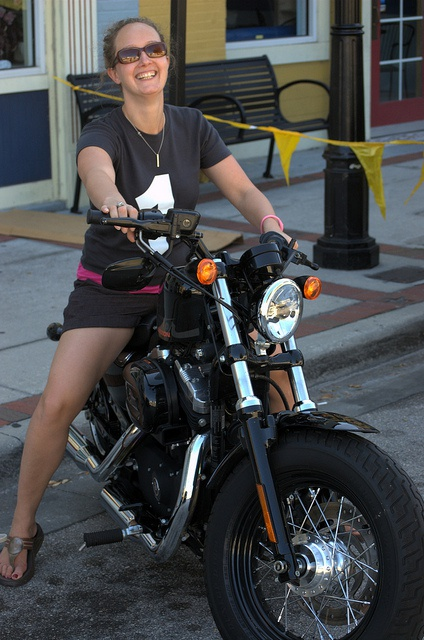Describe the objects in this image and their specific colors. I can see motorcycle in darkgreen, black, gray, navy, and darkblue tones, people in darkgreen, black, gray, and salmon tones, and bench in darkgreen, black, and gray tones in this image. 